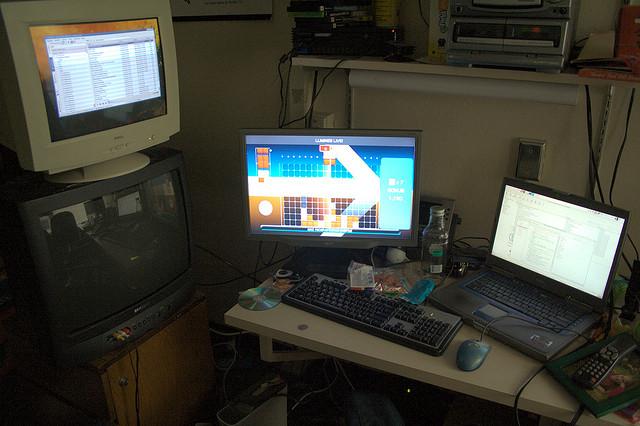Where is the computer?
Short answer required. Desk. Is there paper on the printer?
Short answer required. No. How many screens are there?
Be succinct. 3. What brand of computer?
Give a very brief answer. Dell. Is this a modern room?
Concise answer only. Yes. What are the main differences between these two devices?
Quick response, please. Size. Is the apartment messy?
Short answer required. Yes. Is this a new television?
Answer briefly. No. 